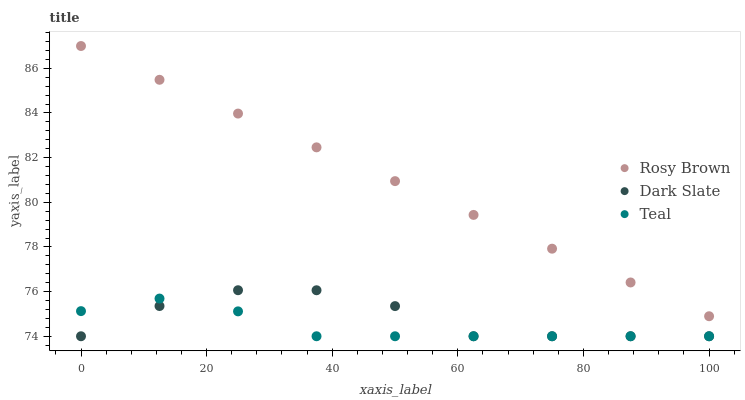Does Teal have the minimum area under the curve?
Answer yes or no. Yes. Does Rosy Brown have the maximum area under the curve?
Answer yes or no. Yes. Does Rosy Brown have the minimum area under the curve?
Answer yes or no. No. Does Teal have the maximum area under the curve?
Answer yes or no. No. Is Rosy Brown the smoothest?
Answer yes or no. Yes. Is Dark Slate the roughest?
Answer yes or no. Yes. Is Teal the smoothest?
Answer yes or no. No. Is Teal the roughest?
Answer yes or no. No. Does Dark Slate have the lowest value?
Answer yes or no. Yes. Does Rosy Brown have the lowest value?
Answer yes or no. No. Does Rosy Brown have the highest value?
Answer yes or no. Yes. Does Teal have the highest value?
Answer yes or no. No. Is Dark Slate less than Rosy Brown?
Answer yes or no. Yes. Is Rosy Brown greater than Teal?
Answer yes or no. Yes. Does Teal intersect Dark Slate?
Answer yes or no. Yes. Is Teal less than Dark Slate?
Answer yes or no. No. Is Teal greater than Dark Slate?
Answer yes or no. No. Does Dark Slate intersect Rosy Brown?
Answer yes or no. No. 